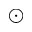Convert formula to latex. <formula><loc_0><loc_0><loc_500><loc_500>\odot</formula> 